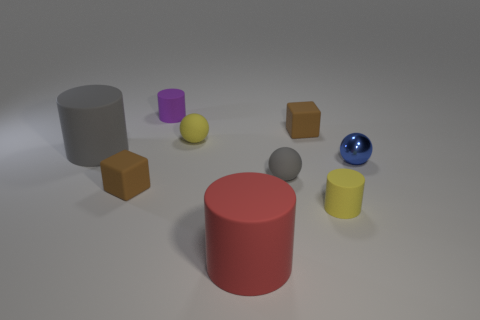Add 1 tiny brown rubber things. How many objects exist? 10 Subtract all yellow matte cylinders. How many cylinders are left? 3 Subtract 2 cylinders. How many cylinders are left? 2 Subtract all cubes. How many objects are left? 7 Subtract 1 red cylinders. How many objects are left? 8 Subtract all brown balls. Subtract all gray cylinders. How many balls are left? 3 Subtract all tiny red rubber objects. Subtract all yellow objects. How many objects are left? 7 Add 2 blue metallic spheres. How many blue metallic spheres are left? 3 Add 5 yellow things. How many yellow things exist? 7 